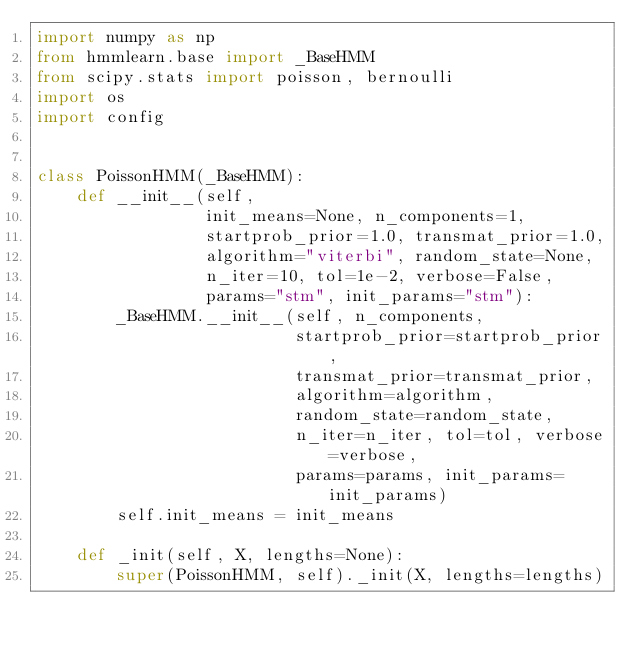<code> <loc_0><loc_0><loc_500><loc_500><_Python_>import numpy as np
from hmmlearn.base import _BaseHMM
from scipy.stats import poisson, bernoulli
import os
import config


class PoissonHMM(_BaseHMM):
    def __init__(self,
                 init_means=None, n_components=1,
                 startprob_prior=1.0, transmat_prior=1.0,
                 algorithm="viterbi", random_state=None,
                 n_iter=10, tol=1e-2, verbose=False,
                 params="stm", init_params="stm"):
        _BaseHMM.__init__(self, n_components,
                          startprob_prior=startprob_prior,
                          transmat_prior=transmat_prior,
                          algorithm=algorithm,
                          random_state=random_state,
                          n_iter=n_iter, tol=tol, verbose=verbose,
                          params=params, init_params=init_params)
        self.init_means = init_means

    def _init(self, X, lengths=None):
        super(PoissonHMM, self)._init(X, lengths=lengths)</code> 